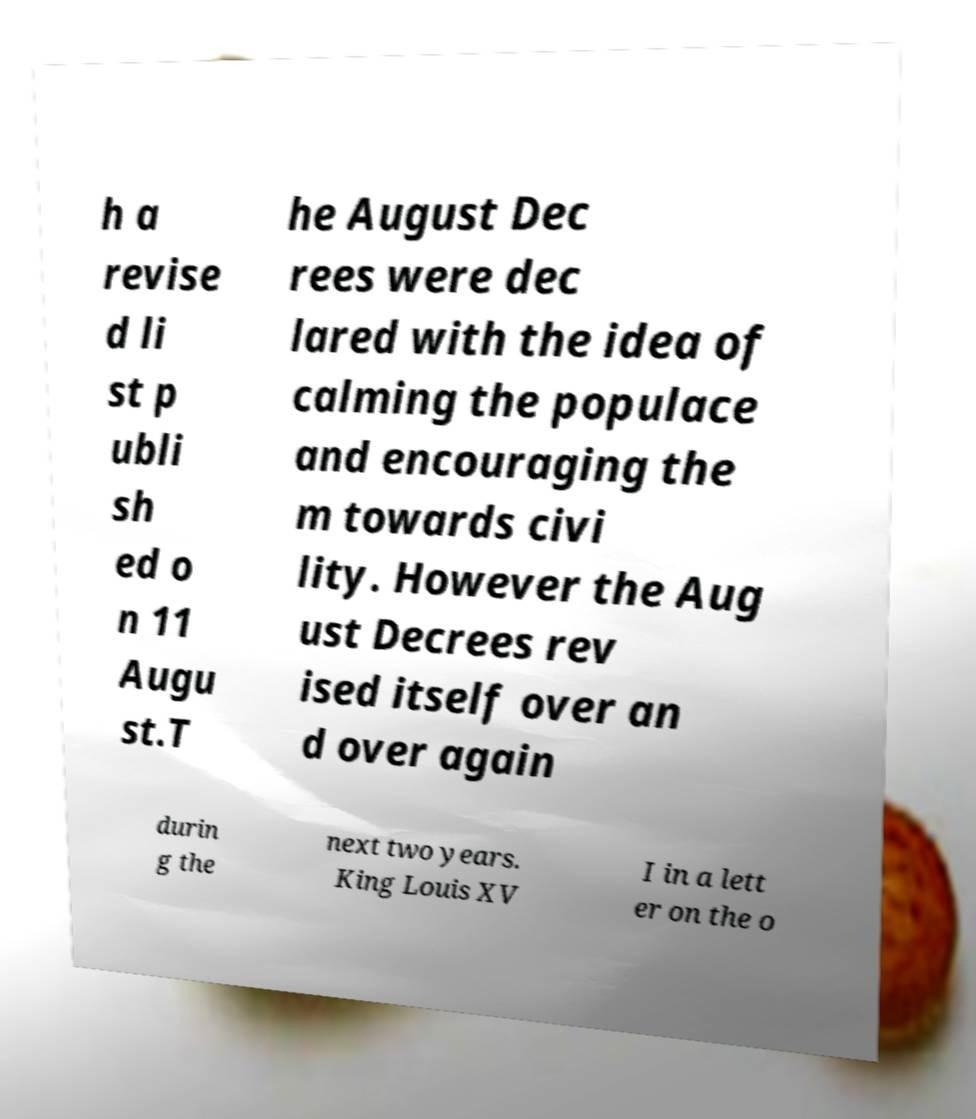Can you read and provide the text displayed in the image?This photo seems to have some interesting text. Can you extract and type it out for me? h a revise d li st p ubli sh ed o n 11 Augu st.T he August Dec rees were dec lared with the idea of calming the populace and encouraging the m towards civi lity. However the Aug ust Decrees rev ised itself over an d over again durin g the next two years. King Louis XV I in a lett er on the o 